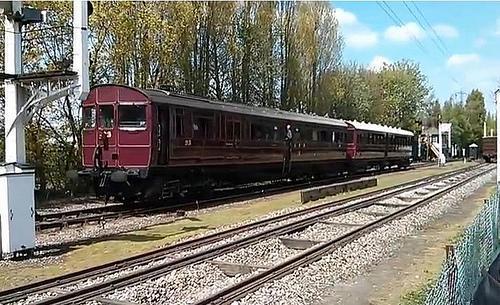How many trains are shown?
Give a very brief answer. 1. 